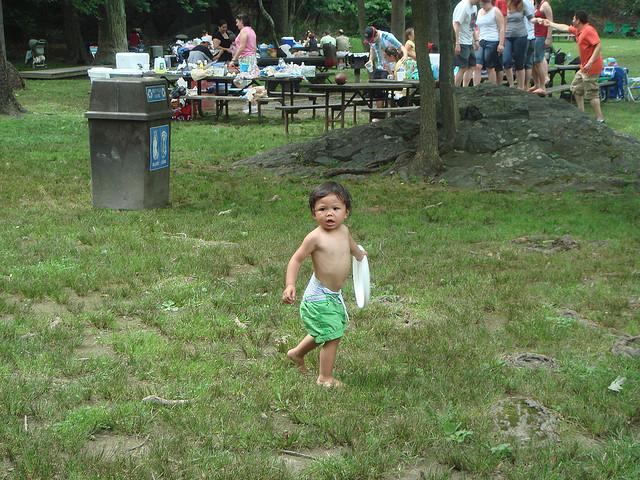If there is any food in this photo where would it be placed?
Concise answer only. Table. Which hand holds a Frisbee?
Short answer required. Left. Is he wearing a shirt?
Give a very brief answer. No. 